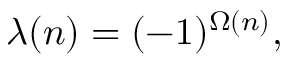Convert formula to latex. <formula><loc_0><loc_0><loc_500><loc_500>\lambda ( n ) = ( - 1 ) ^ { \Omega ( n ) } ,</formula> 